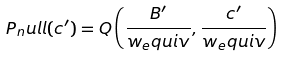<formula> <loc_0><loc_0><loc_500><loc_500>P _ { n } u l l ( c ^ { \prime } ) = Q \left ( \frac { B ^ { \prime } } { w _ { e } q u i v } , \frac { c ^ { \prime } } { w _ { e } q u i v } \right )</formula> 